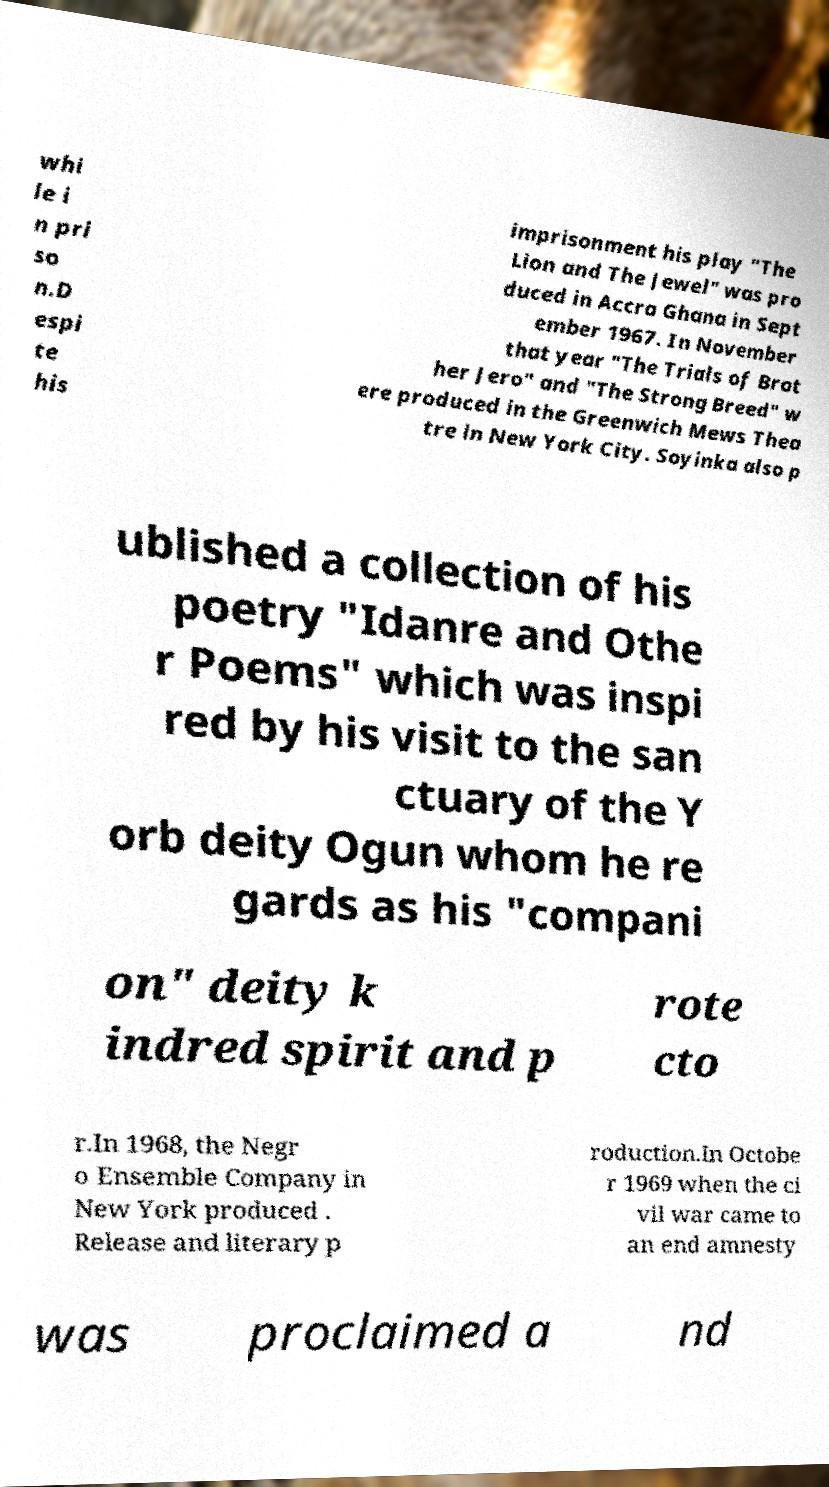I need the written content from this picture converted into text. Can you do that? whi le i n pri so n.D espi te his imprisonment his play "The Lion and The Jewel" was pro duced in Accra Ghana in Sept ember 1967. In November that year "The Trials of Brot her Jero" and "The Strong Breed" w ere produced in the Greenwich Mews Thea tre in New York City. Soyinka also p ublished a collection of his poetry "Idanre and Othe r Poems" which was inspi red by his visit to the san ctuary of the Y orb deity Ogun whom he re gards as his "compani on" deity k indred spirit and p rote cto r.In 1968, the Negr o Ensemble Company in New York produced . Release and literary p roduction.In Octobe r 1969 when the ci vil war came to an end amnesty was proclaimed a nd 